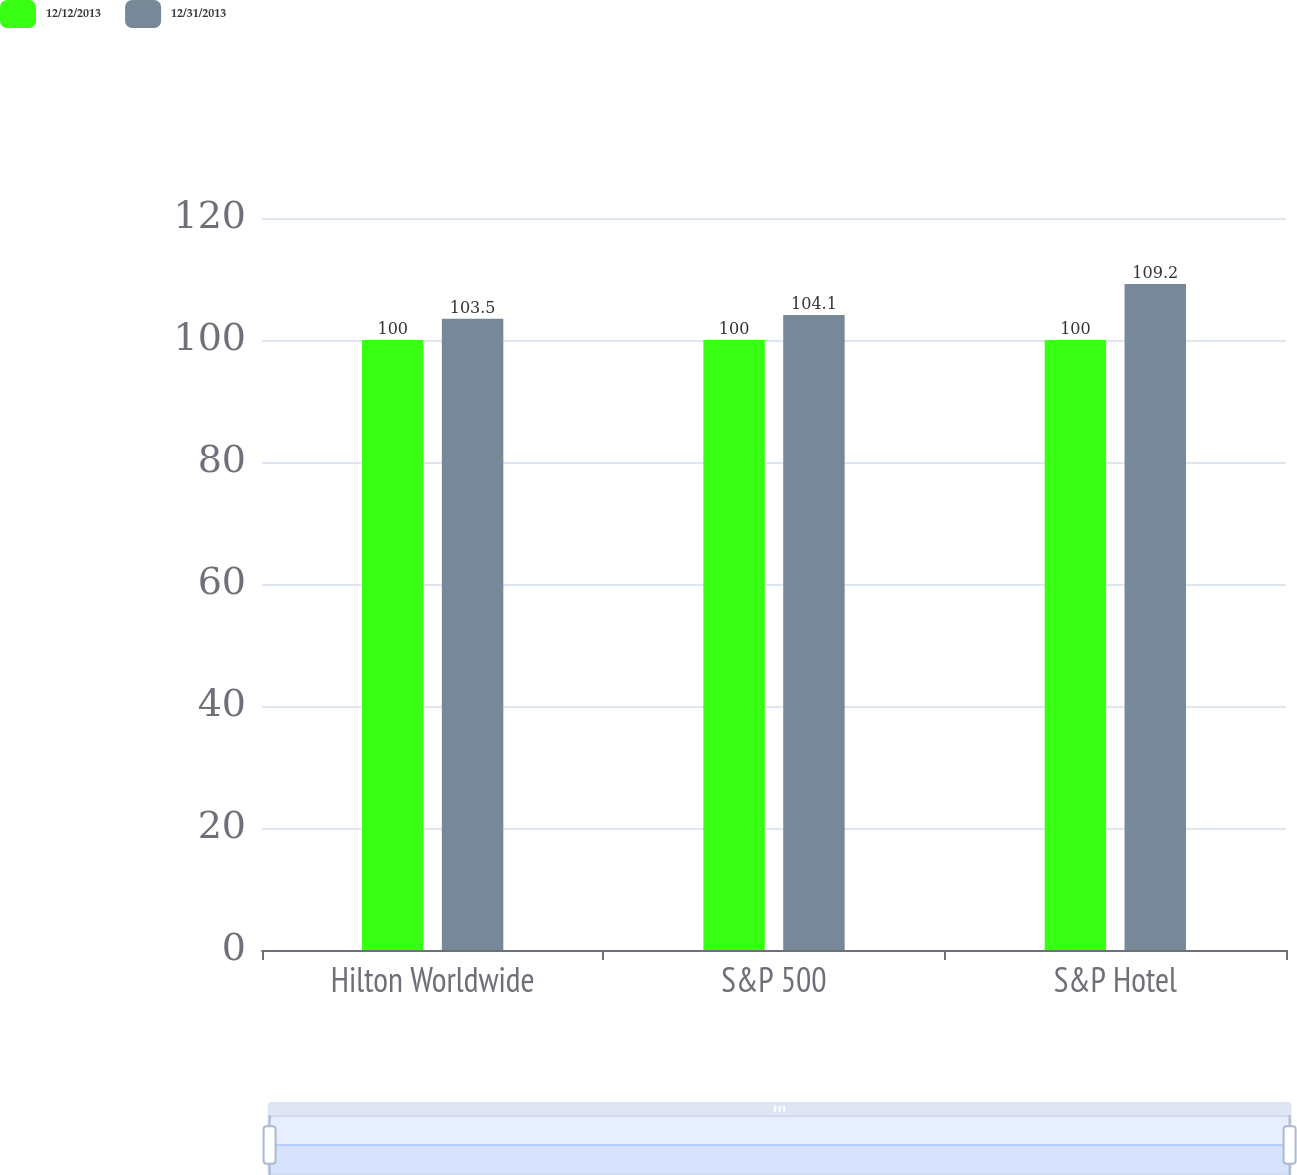Convert chart to OTSL. <chart><loc_0><loc_0><loc_500><loc_500><stacked_bar_chart><ecel><fcel>Hilton Worldwide<fcel>S&P 500<fcel>S&P Hotel<nl><fcel>12/12/2013<fcel>100<fcel>100<fcel>100<nl><fcel>12/31/2013<fcel>103.5<fcel>104.1<fcel>109.2<nl></chart> 